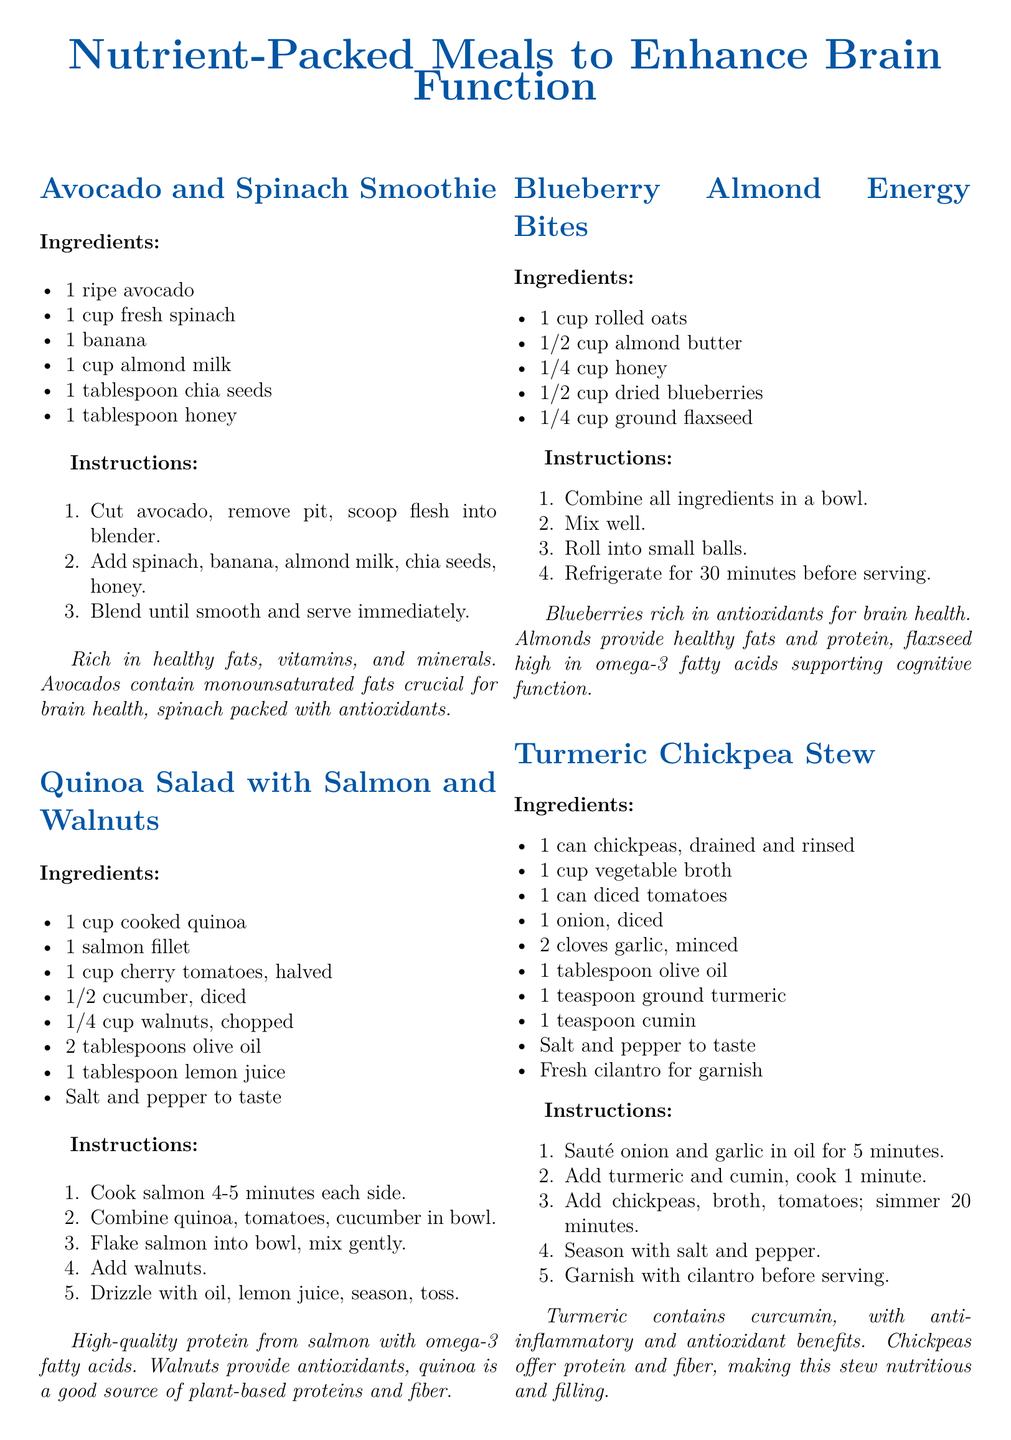What are the ingredients in the Avocado and Spinach Smoothie? The ingredients listed are 1 ripe avocado, 1 cup fresh spinach, 1 banana, 1 cup almond milk, 1 tablespoon chia seeds, and 1 tablespoon honey.
Answer: 1 ripe avocado, 1 cup fresh spinach, 1 banana, 1 cup almond milk, 1 tablespoon chia seeds, 1 tablespoon honey How long should the chickpeas simmer in the Turmeric Chickpea Stew? The instructions mention that the chickpeas should simmer for 20 minutes after adding them to the broth and tomatoes.
Answer: 20 minutes What type of meal is the Blueberry Almond Energy Bites categorized as? The recipe card indicates that these are energy bites made from rolled oats, almond butter, honey, dried blueberries, and ground flaxseed.
Answer: Energy bites What essential fatty acids are mentioned in the document? Omega-3 fatty acids are mentioned as being provided by salmon and flaxseed.
Answer: Omega-3 fatty acids How many tablespoons of olive oil are used in the Quinoa Salad with Salmon and Walnuts? The recipe specifies that 2 tablespoons of olive oil are required for the salad preparation.
Answer: 2 tablespoons 